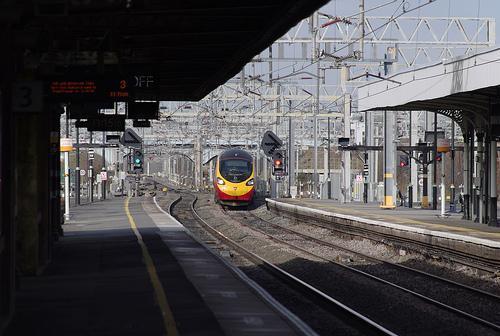How many trains are coming?
Give a very brief answer. 1. 